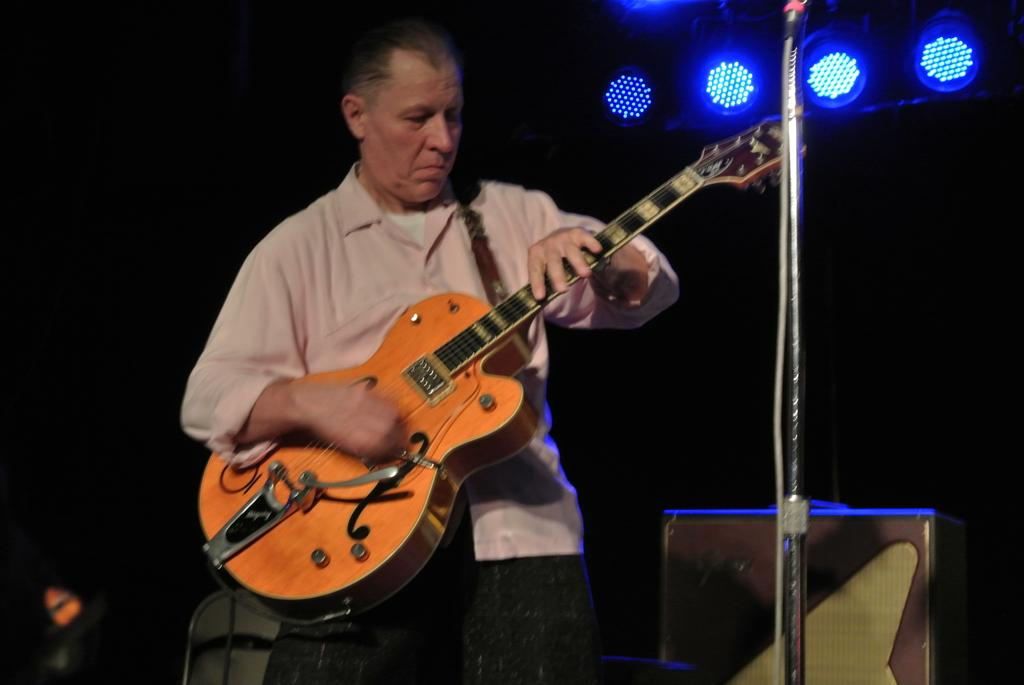What is the main subject of the image? There is a person in the image. What is the person doing in the image? The person is standing and holding a guitar in their hand. Is there any equipment related to the guitar in the image? Yes, there is a guitar stand in the image. What can be seen in the background of the image? There are lights visible in the background. What type of note is the person singing in the image? There is no indication in the image that the person is singing, so it cannot be determined what type of note they might be singing. Can you hear the sound of bells in the image? There is no sound present in the image, so it cannot be determined if bells can be heard. 